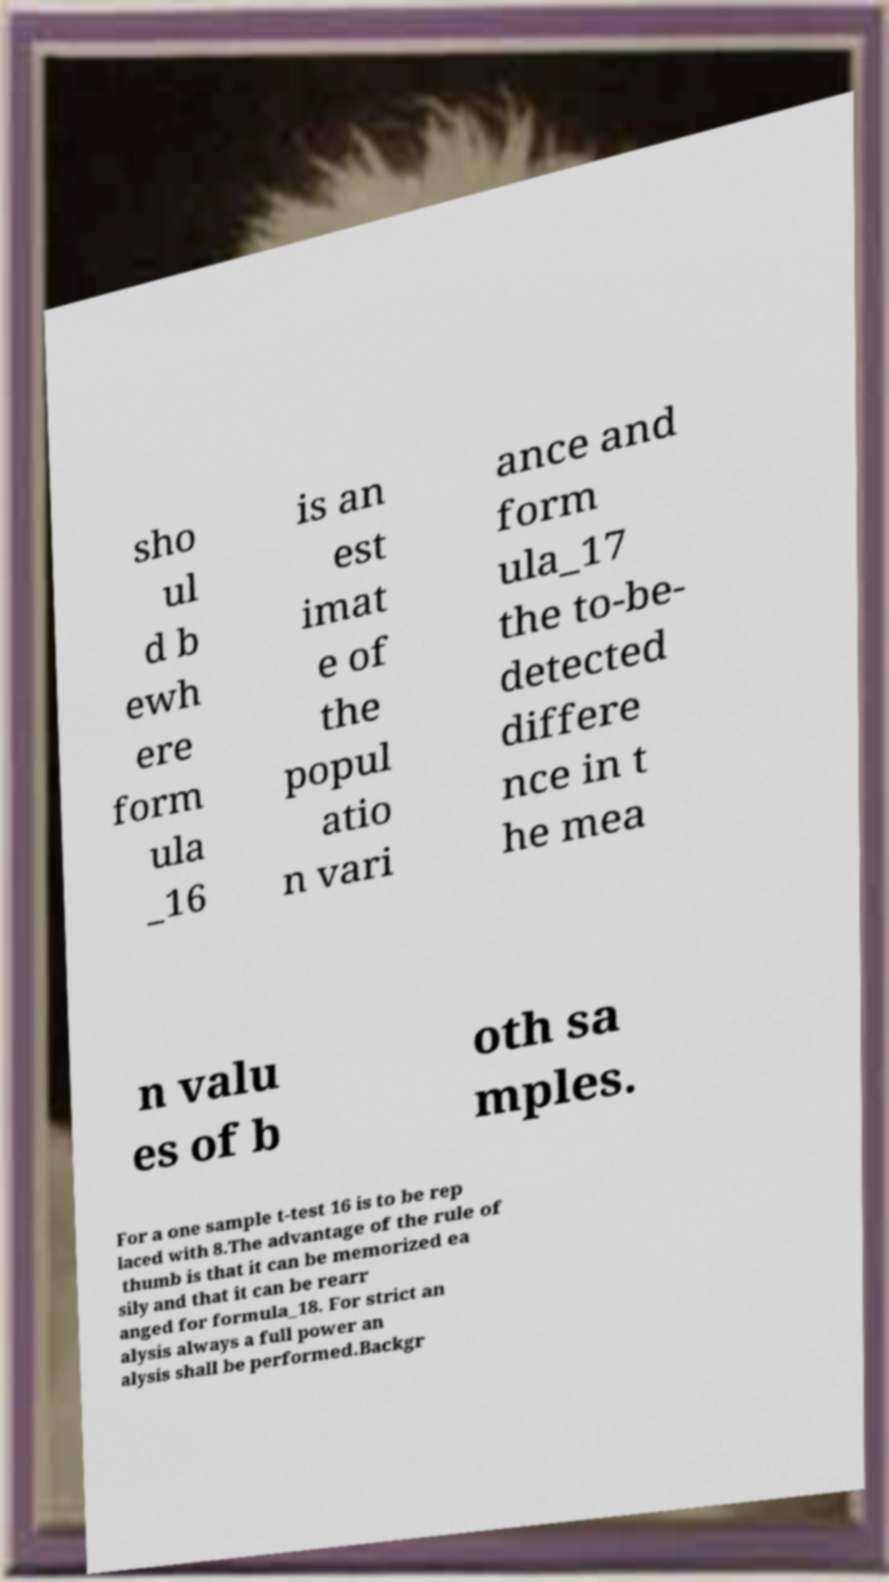I need the written content from this picture converted into text. Can you do that? sho ul d b ewh ere form ula _16 is an est imat e of the popul atio n vari ance and form ula_17 the to-be- detected differe nce in t he mea n valu es of b oth sa mples. For a one sample t-test 16 is to be rep laced with 8.The advantage of the rule of thumb is that it can be memorized ea sily and that it can be rearr anged for formula_18. For strict an alysis always a full power an alysis shall be performed.Backgr 